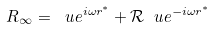Convert formula to latex. <formula><loc_0><loc_0><loc_500><loc_500>R _ { \infty } = \ u e ^ { i \omega r ^ { * } } + \mathcal { R } \ u e ^ { - i \omega r ^ { * } }</formula> 